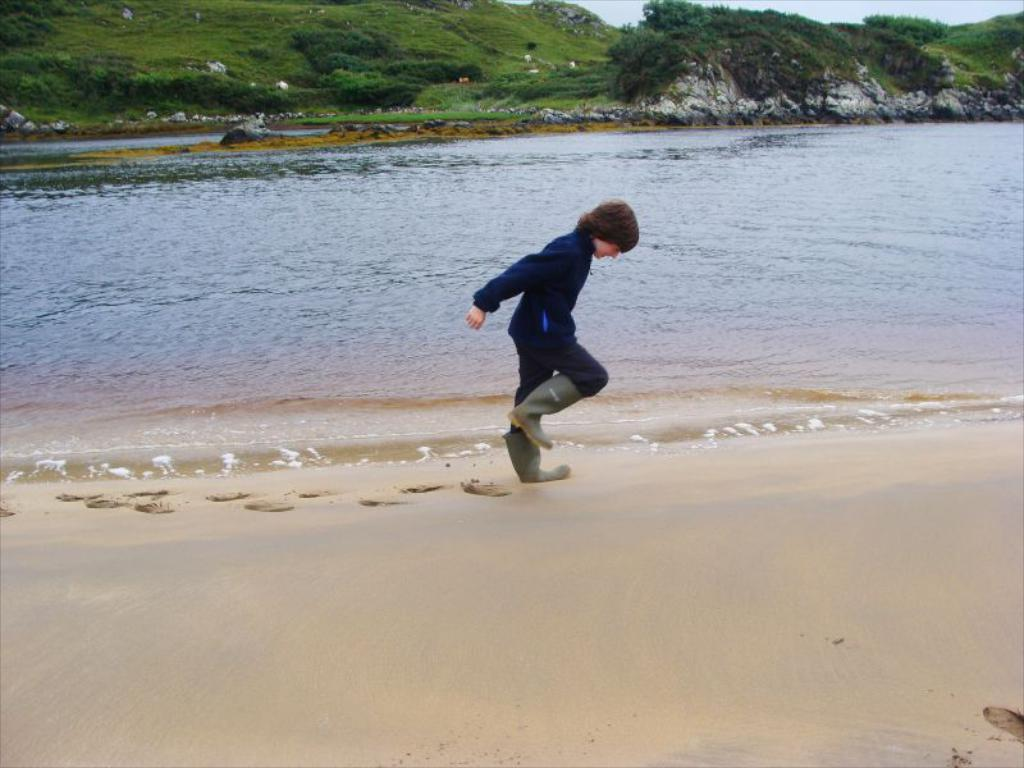Who is present in the image? There is a boy in the image. What is visible in the image besides the boy? Water is visible in the image. What can be seen in the background of the image? There is grass and plants in the background of the image. What type of goat can be seen interacting with the scarecrow in the image? There is no goat or scarecrow present in the image; it only features a boy and some water and plants in the background. 